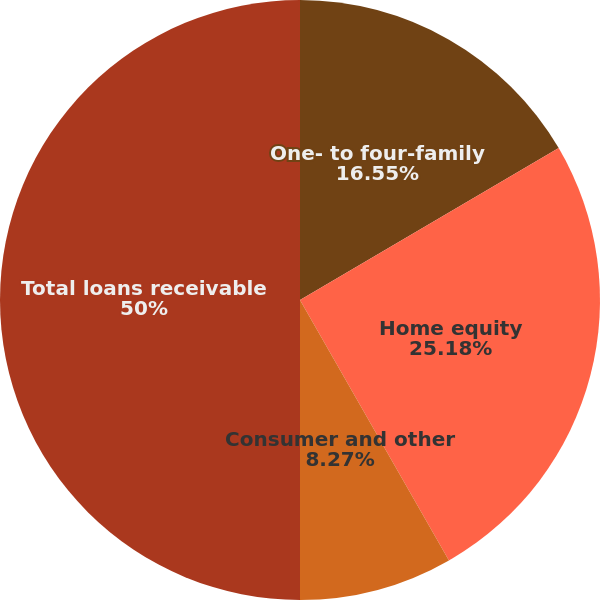<chart> <loc_0><loc_0><loc_500><loc_500><pie_chart><fcel>One- to four-family<fcel>Home equity<fcel>Consumer and other<fcel>Total loans receivable<nl><fcel>16.55%<fcel>25.18%<fcel>8.27%<fcel>50.0%<nl></chart> 